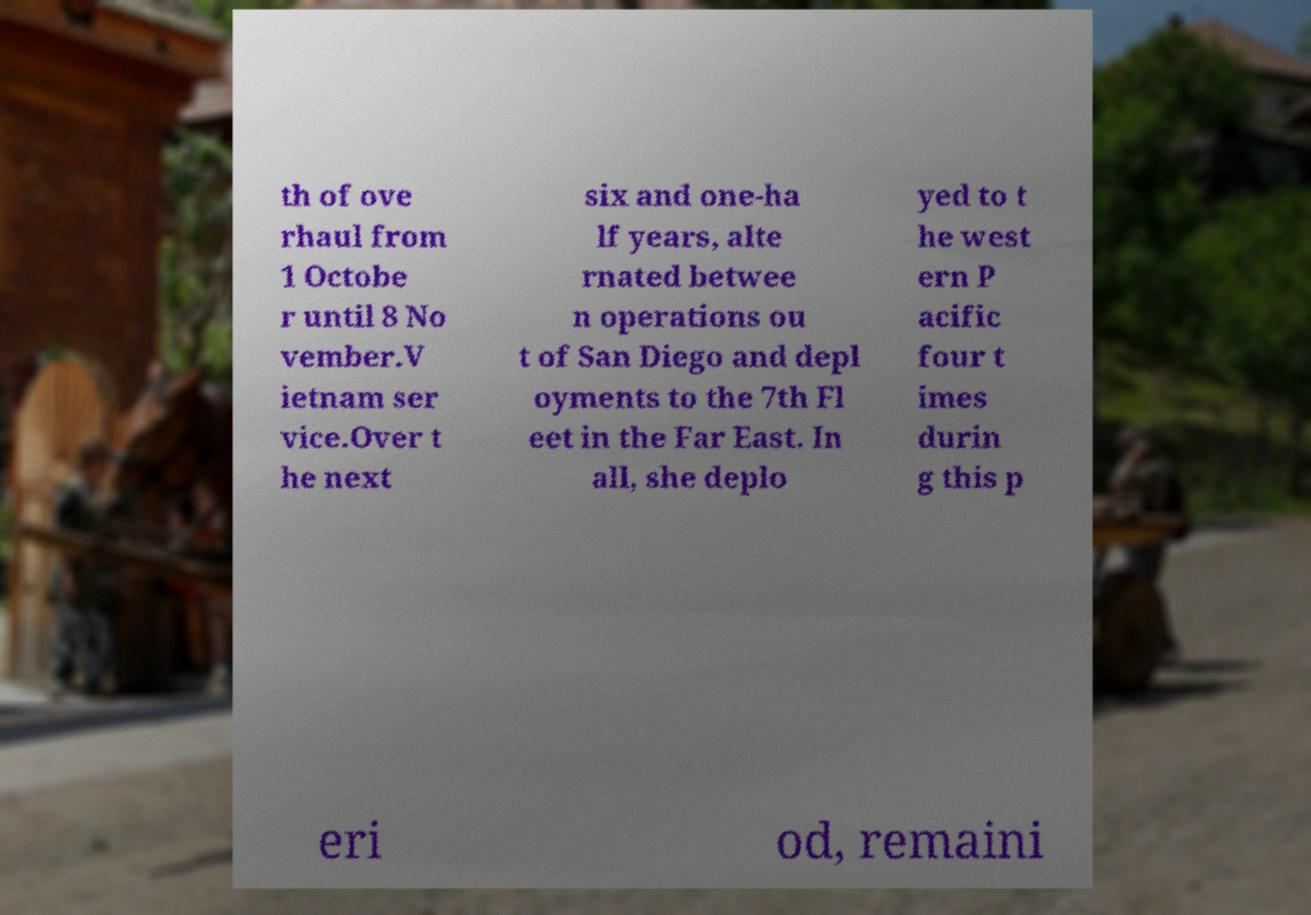Can you accurately transcribe the text from the provided image for me? th of ove rhaul from 1 Octobe r until 8 No vember.V ietnam ser vice.Over t he next six and one-ha lf years, alte rnated betwee n operations ou t of San Diego and depl oyments to the 7th Fl eet in the Far East. In all, she deplo yed to t he west ern P acific four t imes durin g this p eri od, remaini 